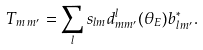Convert formula to latex. <formula><loc_0><loc_0><loc_500><loc_500>T _ { m \, m ^ { \prime } } = \sum _ { l } s _ { l m } d ^ { l } _ { m m ^ { \prime } } ( \theta _ { E } ) b ^ { \ast } _ { l \, m ^ { \prime } } .</formula> 